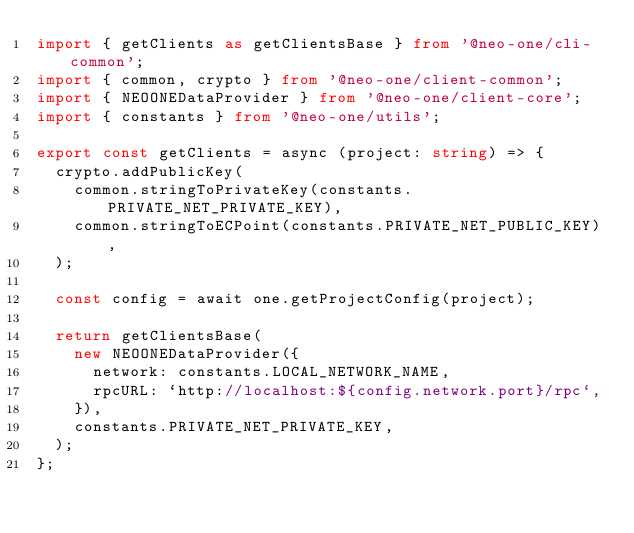<code> <loc_0><loc_0><loc_500><loc_500><_TypeScript_>import { getClients as getClientsBase } from '@neo-one/cli-common';
import { common, crypto } from '@neo-one/client-common';
import { NEOONEDataProvider } from '@neo-one/client-core';
import { constants } from '@neo-one/utils';

export const getClients = async (project: string) => {
  crypto.addPublicKey(
    common.stringToPrivateKey(constants.PRIVATE_NET_PRIVATE_KEY),
    common.stringToECPoint(constants.PRIVATE_NET_PUBLIC_KEY),
  );

  const config = await one.getProjectConfig(project);

  return getClientsBase(
    new NEOONEDataProvider({
      network: constants.LOCAL_NETWORK_NAME,
      rpcURL: `http://localhost:${config.network.port}/rpc`,
    }),
    constants.PRIVATE_NET_PRIVATE_KEY,
  );
};
</code> 